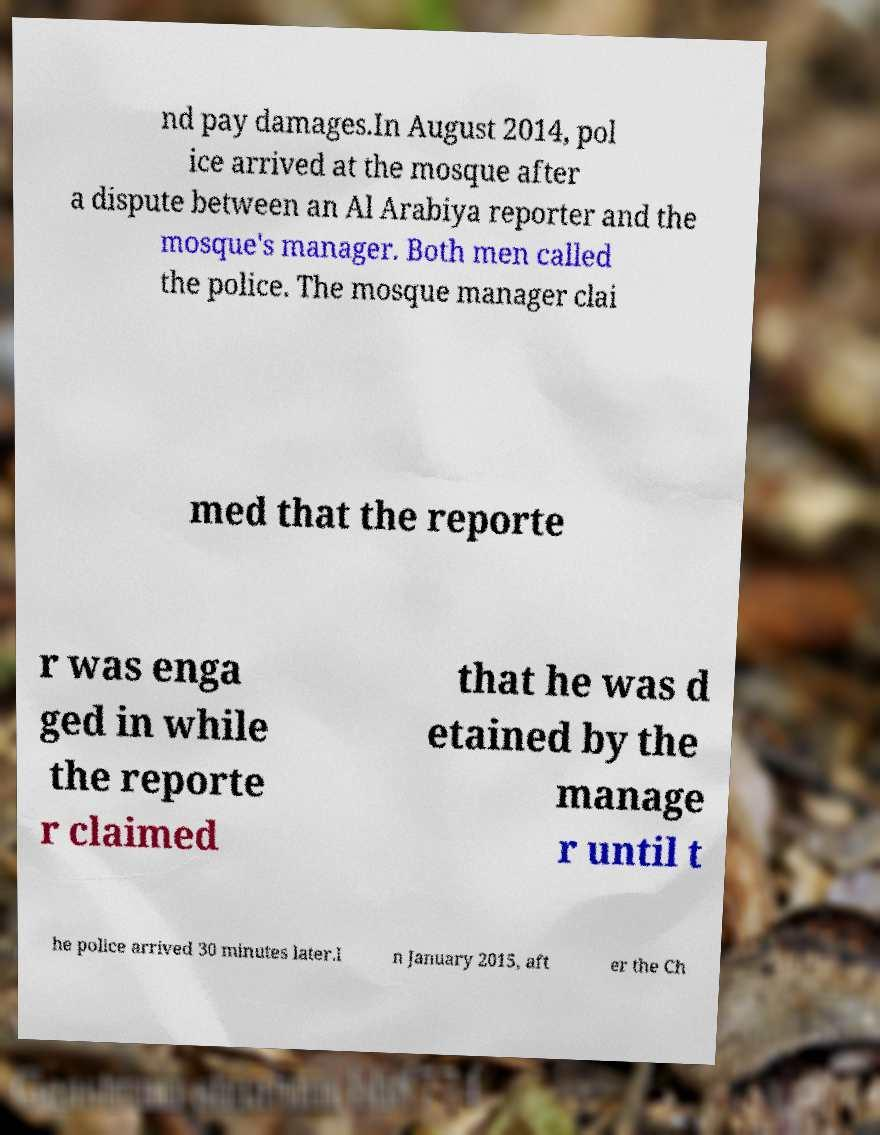Can you read and provide the text displayed in the image?This photo seems to have some interesting text. Can you extract and type it out for me? nd pay damages.In August 2014, pol ice arrived at the mosque after a dispute between an Al Arabiya reporter and the mosque's manager. Both men called the police. The mosque manager clai med that the reporte r was enga ged in while the reporte r claimed that he was d etained by the manage r until t he police arrived 30 minutes later.I n January 2015, aft er the Ch 